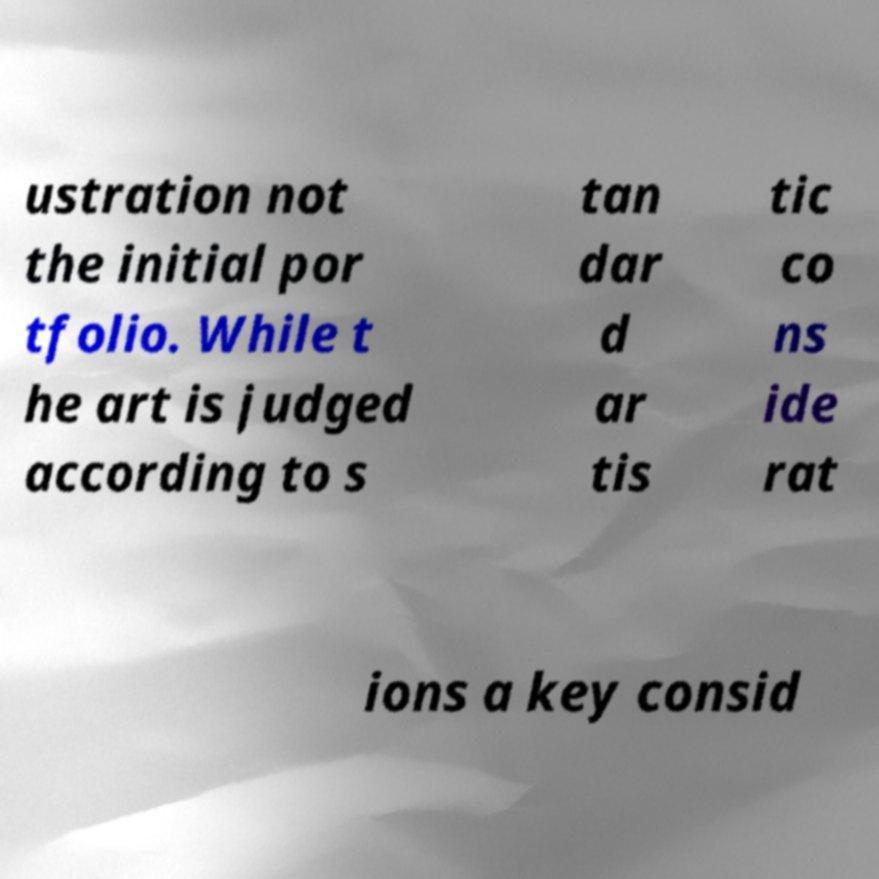There's text embedded in this image that I need extracted. Can you transcribe it verbatim? ustration not the initial por tfolio. While t he art is judged according to s tan dar d ar tis tic co ns ide rat ions a key consid 